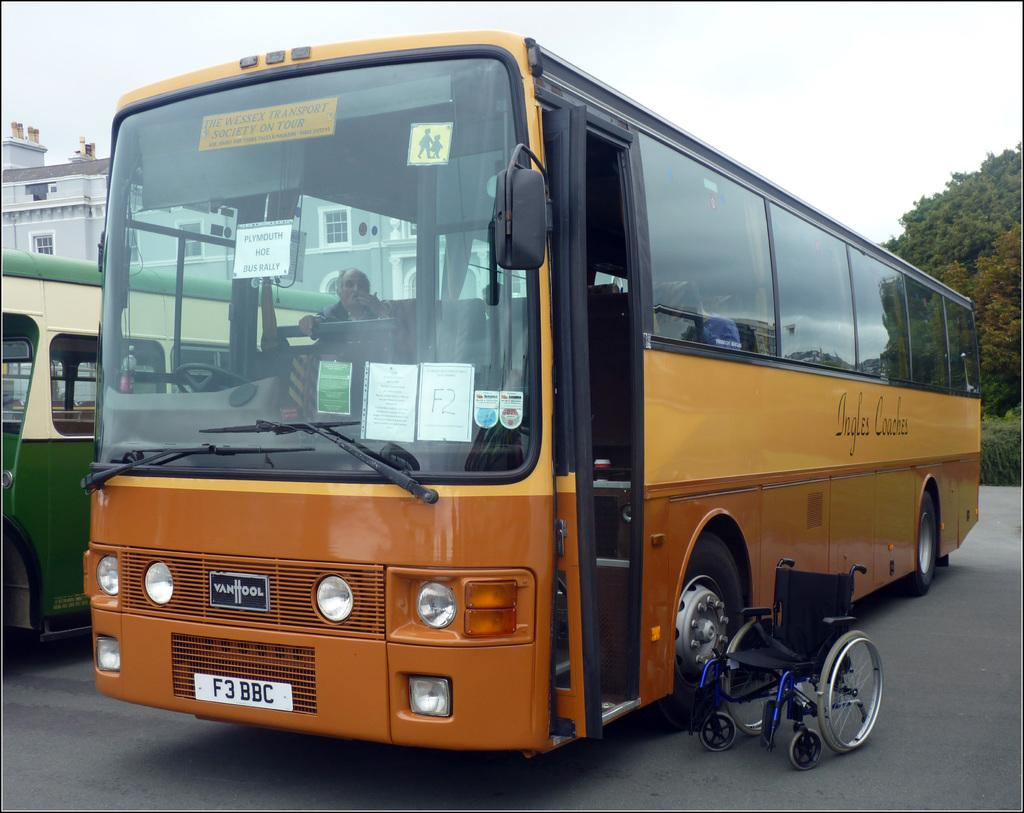<image>
Relay a brief, clear account of the picture shown. a bus with the letters 'f3bbc' on the front license plates 